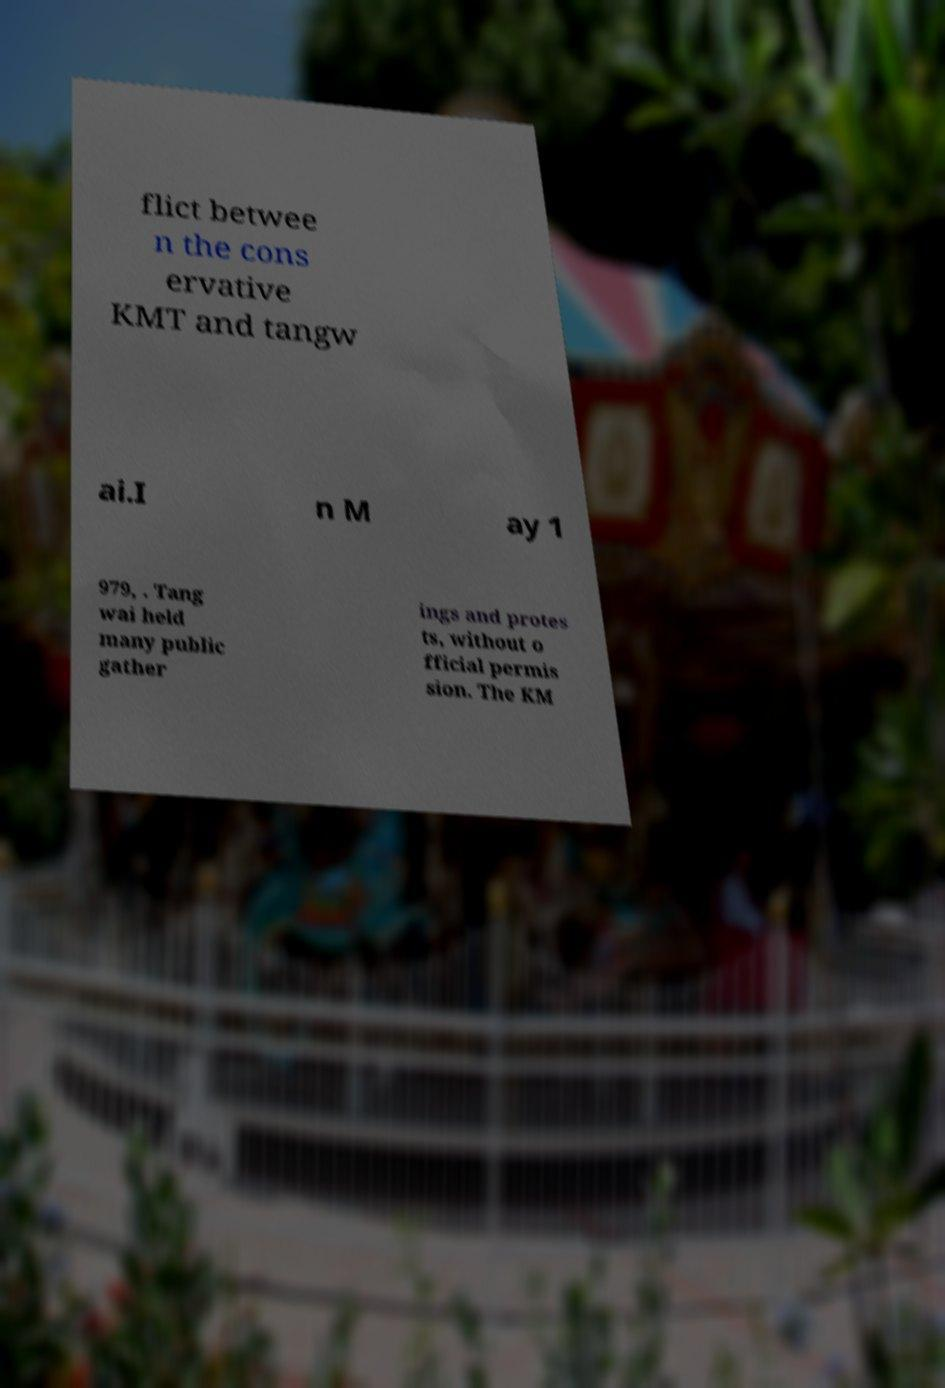I need the written content from this picture converted into text. Can you do that? flict betwee n the cons ervative KMT and tangw ai.I n M ay 1 979, . Tang wai held many public gather ings and protes ts, without o fficial permis sion. The KM 